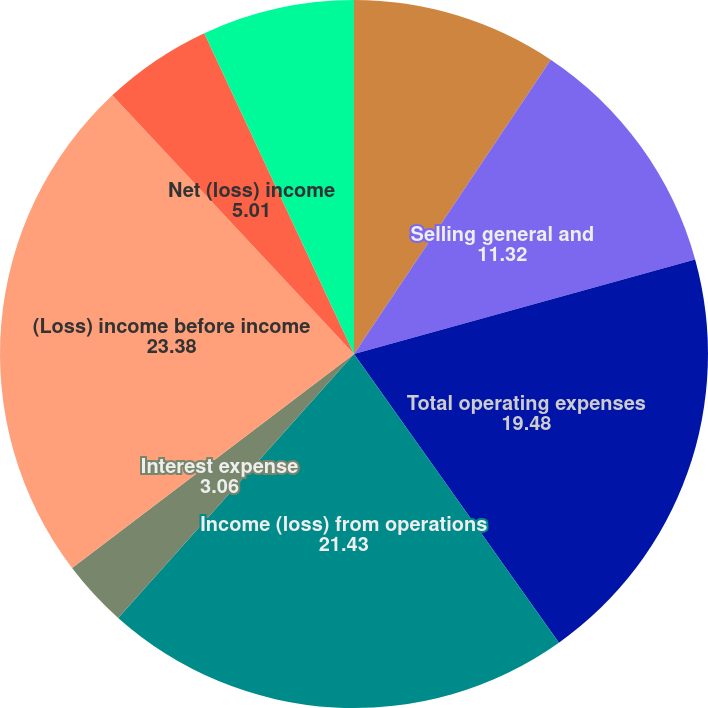Convert chart. <chart><loc_0><loc_0><loc_500><loc_500><pie_chart><fcel>Research and development<fcel>Selling general and<fcel>Total operating expenses<fcel>Income (loss) from operations<fcel>Interest expense<fcel>(Loss) income before income<fcel>Net (loss) income<fcel>Comprehensive (loss) income<nl><fcel>9.38%<fcel>11.32%<fcel>19.48%<fcel>21.43%<fcel>3.06%<fcel>23.38%<fcel>5.01%<fcel>6.95%<nl></chart> 